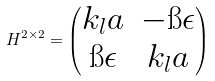<formula> <loc_0><loc_0><loc_500><loc_500>H ^ { 2 \times 2 } = \begin{pmatrix} k _ { l } a & - \i \epsilon \\ \i \epsilon & k _ { l } a \end{pmatrix}</formula> 